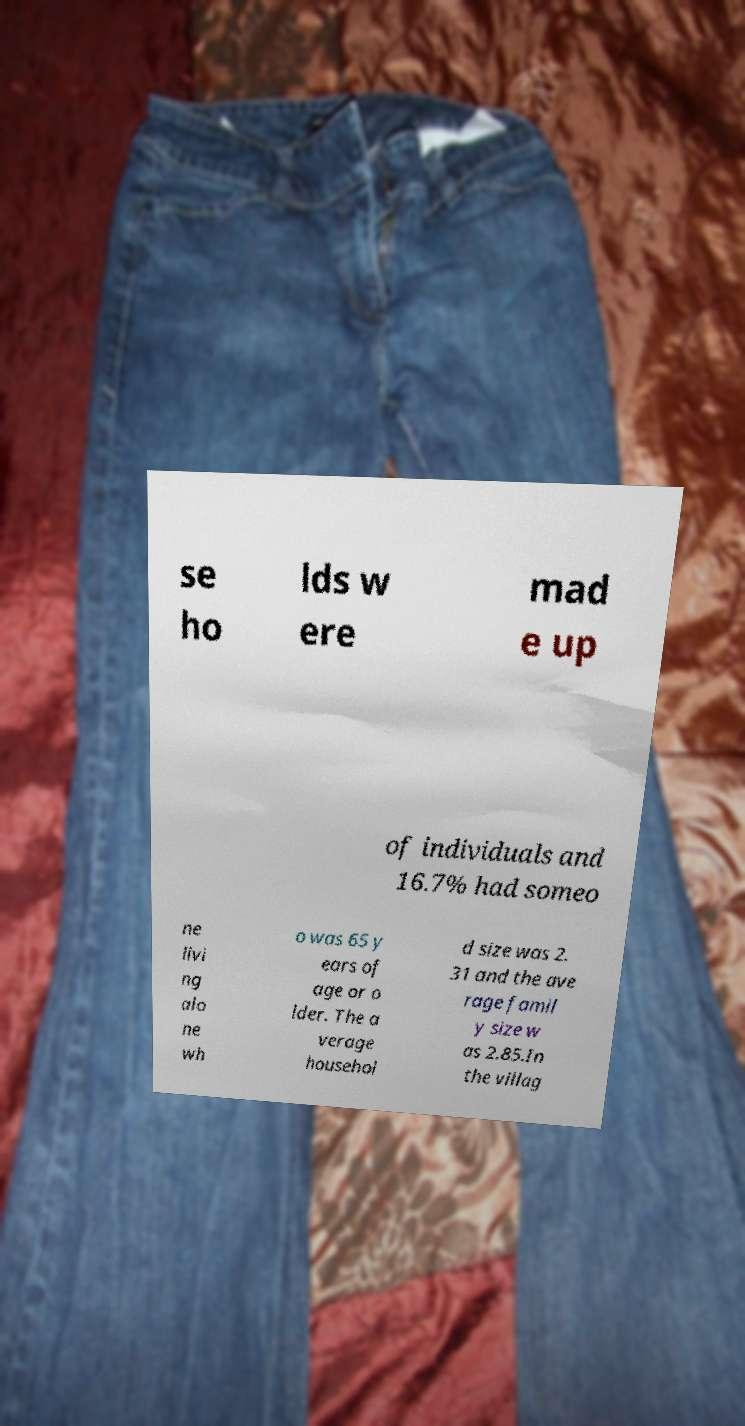What messages or text are displayed in this image? I need them in a readable, typed format. se ho lds w ere mad e up of individuals and 16.7% had someo ne livi ng alo ne wh o was 65 y ears of age or o lder. The a verage househol d size was 2. 31 and the ave rage famil y size w as 2.85.In the villag 